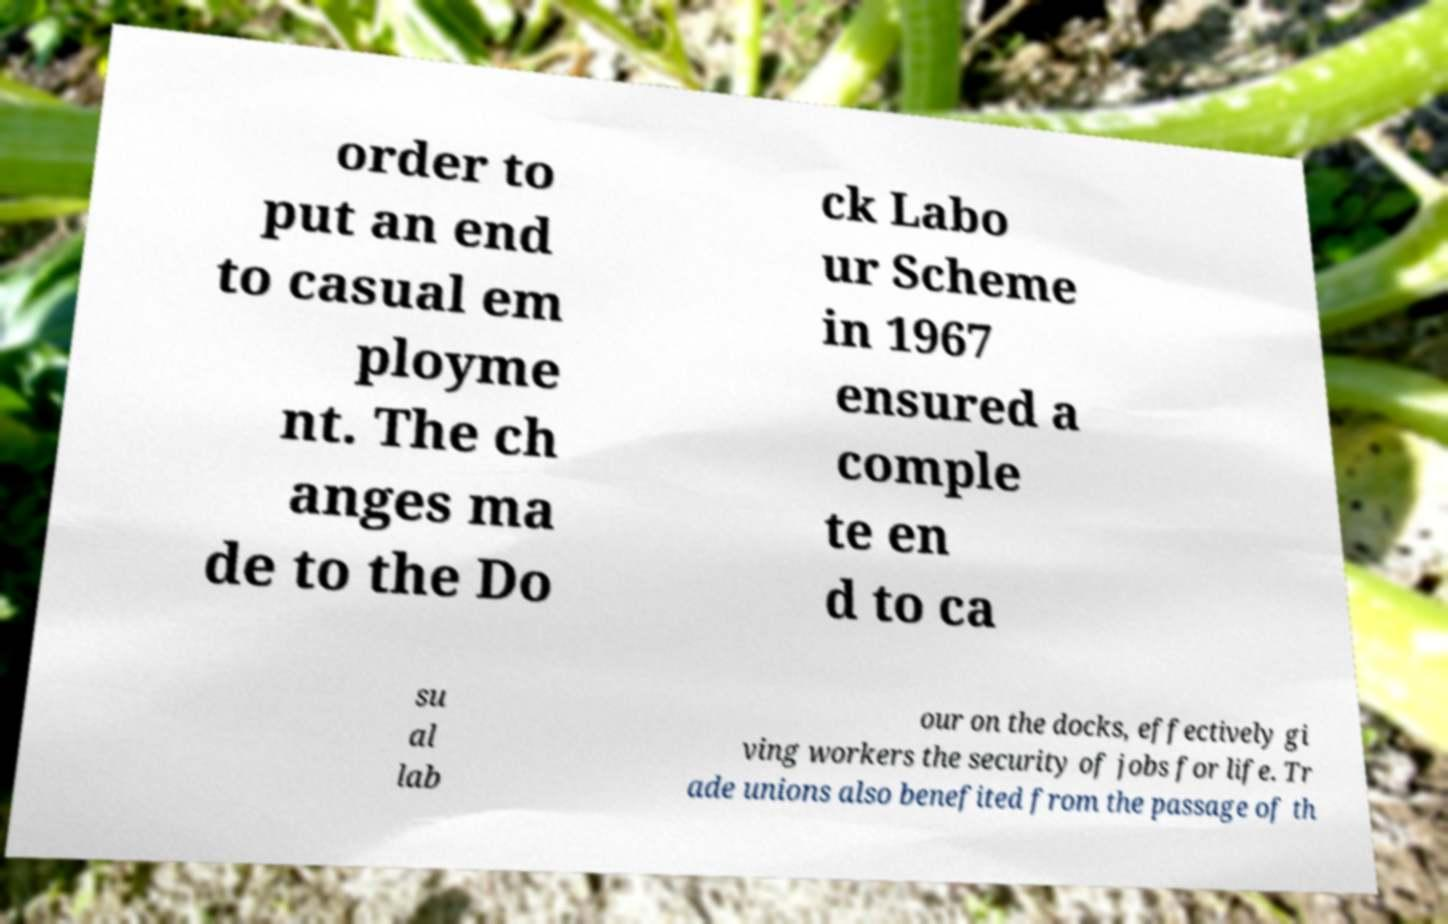I need the written content from this picture converted into text. Can you do that? order to put an end to casual em ployme nt. The ch anges ma de to the Do ck Labo ur Scheme in 1967 ensured a comple te en d to ca su al lab our on the docks, effectively gi ving workers the security of jobs for life. Tr ade unions also benefited from the passage of th 